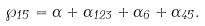<formula> <loc_0><loc_0><loc_500><loc_500>\wp _ { 1 5 } = \alpha + \alpha _ { 1 2 3 } + \alpha _ { 6 } + \alpha _ { 4 5 } .</formula> 